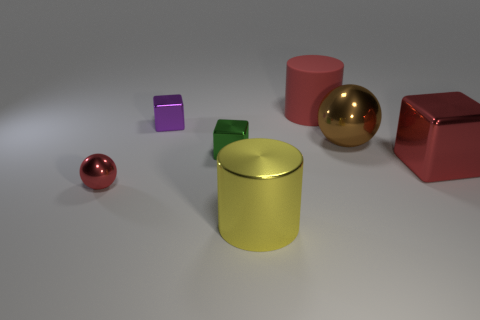Add 2 large purple balls. How many objects exist? 9 Subtract all cylinders. How many objects are left? 5 Subtract 0 yellow blocks. How many objects are left? 7 Subtract all gray blocks. Subtract all cylinders. How many objects are left? 5 Add 4 red things. How many red things are left? 7 Add 7 yellow balls. How many yellow balls exist? 7 